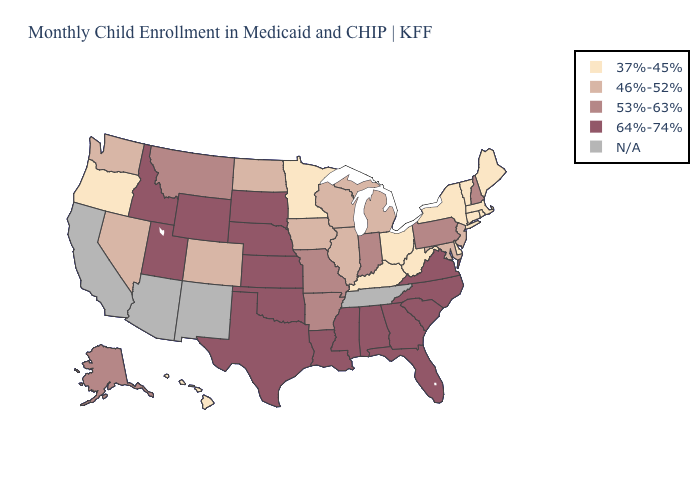Does the first symbol in the legend represent the smallest category?
Short answer required. Yes. What is the value of West Virginia?
Answer briefly. 37%-45%. What is the value of Louisiana?
Give a very brief answer. 64%-74%. What is the lowest value in the USA?
Keep it brief. 37%-45%. What is the value of South Dakota?
Write a very short answer. 64%-74%. Name the states that have a value in the range 46%-52%?
Answer briefly. Colorado, Illinois, Iowa, Maryland, Michigan, Nevada, New Jersey, North Dakota, Washington, Wisconsin. What is the value of Florida?
Give a very brief answer. 64%-74%. How many symbols are there in the legend?
Answer briefly. 5. Does the map have missing data?
Short answer required. Yes. What is the value of Texas?
Answer briefly. 64%-74%. Among the states that border New York , which have the lowest value?
Short answer required. Connecticut, Massachusetts, Vermont. Does New Jersey have the lowest value in the USA?
Keep it brief. No. 